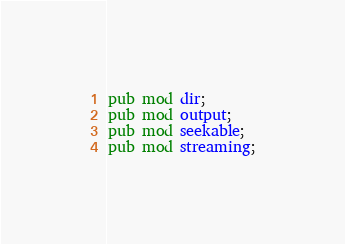Convert code to text. <code><loc_0><loc_0><loc_500><loc_500><_Rust_>pub mod dir;
pub mod output;
pub mod seekable;
pub mod streaming;
</code> 